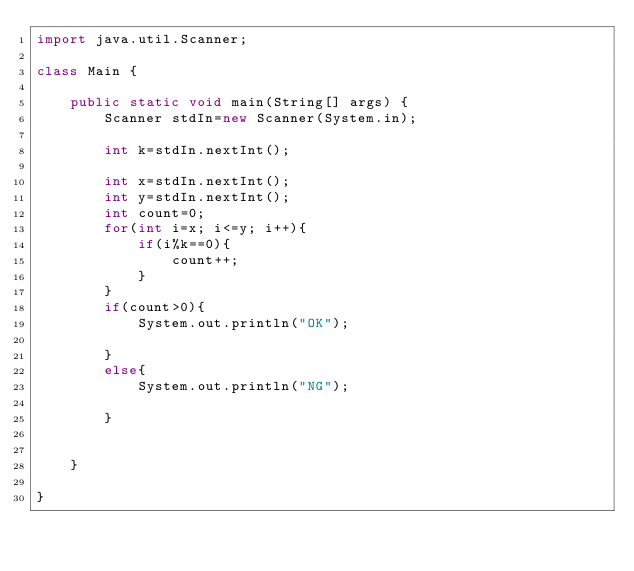<code> <loc_0><loc_0><loc_500><loc_500><_Java_>import java.util.Scanner;

class Main {

    public static void main(String[] args) {
        Scanner stdIn=new Scanner(System.in);

        int k=stdIn.nextInt();

        int x=stdIn.nextInt();
        int y=stdIn.nextInt();
        int count=0;
        for(int i=x; i<=y; i++){
            if(i%k==0){
                count++;
            }
        }
        if(count>0){
            System.out.println("OK");
            
        }
        else{
            System.out.println("NG");
            
        }
        
        
    }

}</code> 